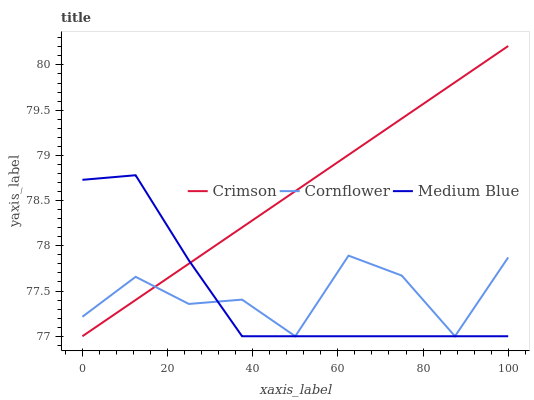Does Medium Blue have the minimum area under the curve?
Answer yes or no. Yes. Does Crimson have the maximum area under the curve?
Answer yes or no. Yes. Does Cornflower have the minimum area under the curve?
Answer yes or no. No. Does Cornflower have the maximum area under the curve?
Answer yes or no. No. Is Crimson the smoothest?
Answer yes or no. Yes. Is Cornflower the roughest?
Answer yes or no. Yes. Is Medium Blue the smoothest?
Answer yes or no. No. Is Medium Blue the roughest?
Answer yes or no. No. Does Crimson have the lowest value?
Answer yes or no. Yes. Does Crimson have the highest value?
Answer yes or no. Yes. Does Medium Blue have the highest value?
Answer yes or no. No. Does Cornflower intersect Crimson?
Answer yes or no. Yes. Is Cornflower less than Crimson?
Answer yes or no. No. Is Cornflower greater than Crimson?
Answer yes or no. No. 